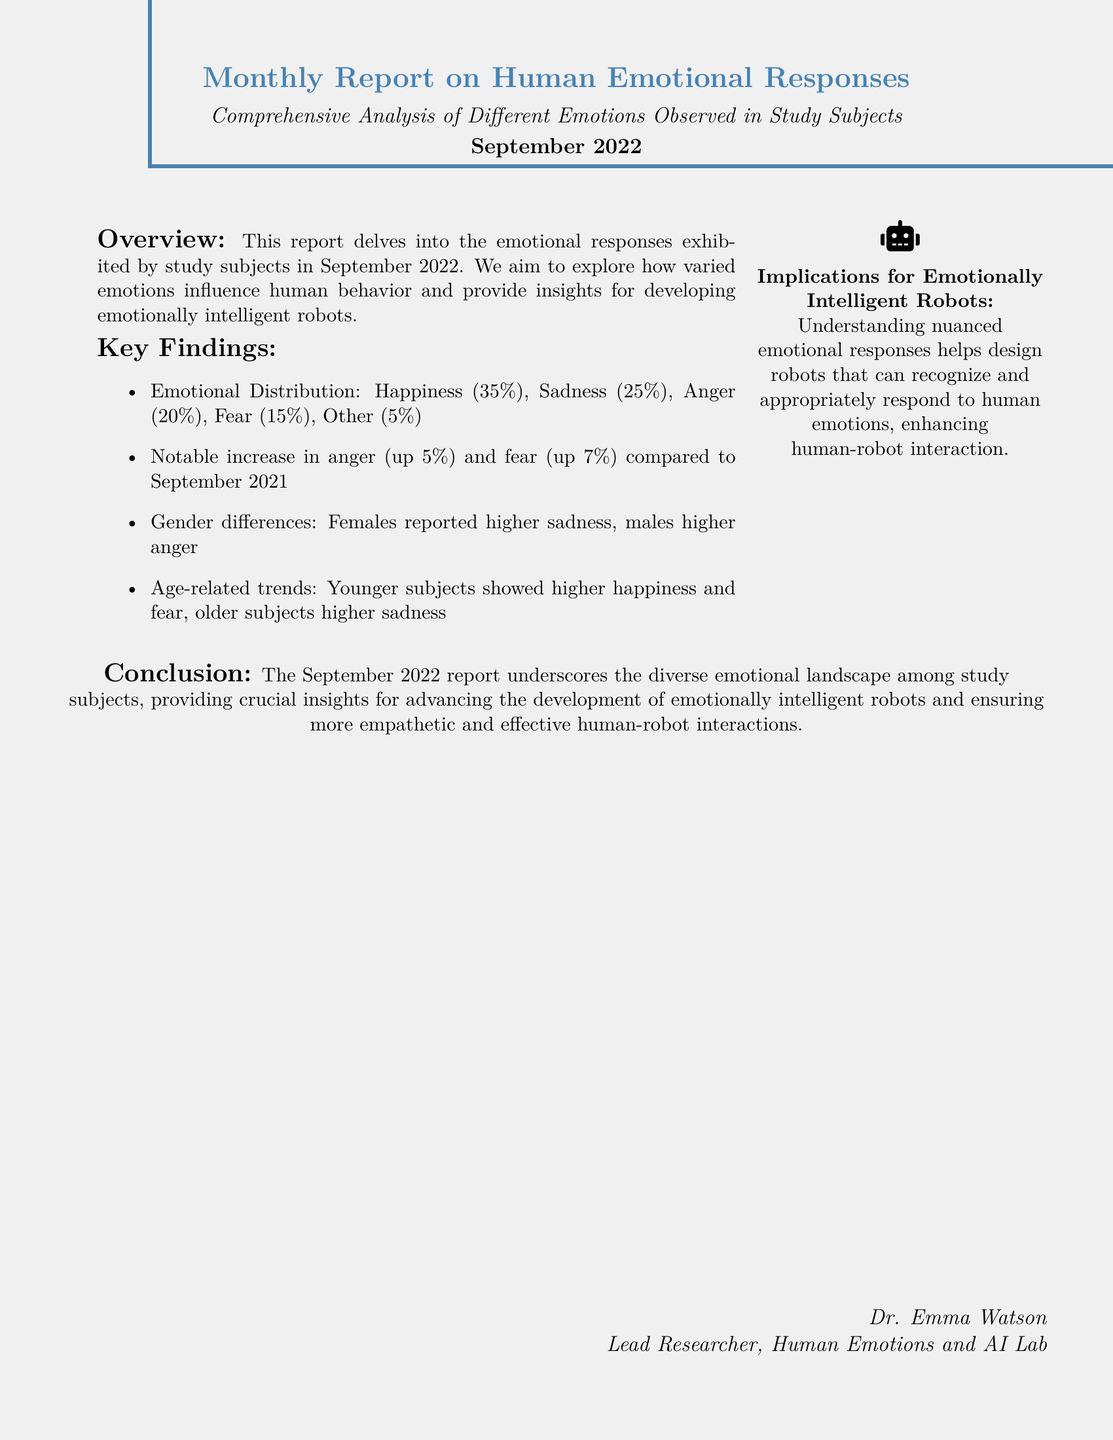What was the emotional distribution of happiness? The emotional distribution indicates that happiness made up 35% of the study subjects' responses.
Answer: 35% What percentage of subjects reported sadness? The report specifies that sadness was reported by 25% of the subjects.
Answer: 25% What notable increases in emotions were observed compared to September 2021? The document mentions notable increases in anger (up 5%) and fear (up 7%).
Answer: Anger, Fear Which gender reported higher levels of sadness? According to the findings, females reported higher levels of sadness than males.
Answer: Females What age group exhibited higher happiness? The report indicates that younger subjects showed higher levels of happiness.
Answer: Younger subjects Who is the lead researcher mentioned in the document? The lead researcher, Dr. Emma Watson, is mentioned at the end of the report.
Answer: Dr. Emma Watson What is the main purpose of the report? The report aims to explore emotional responses and their influence on human behavior for emotionally intelligent robots.
Answer: Explore emotional responses How does the report conclude? The conclusion emphasizes diverse emotional landscapes and insights for advancing emotionally intelligent robots.
Answer: Diverse emotional landscapes What is the publication date of this report? The report is dated September 2022.
Answer: September 2022 